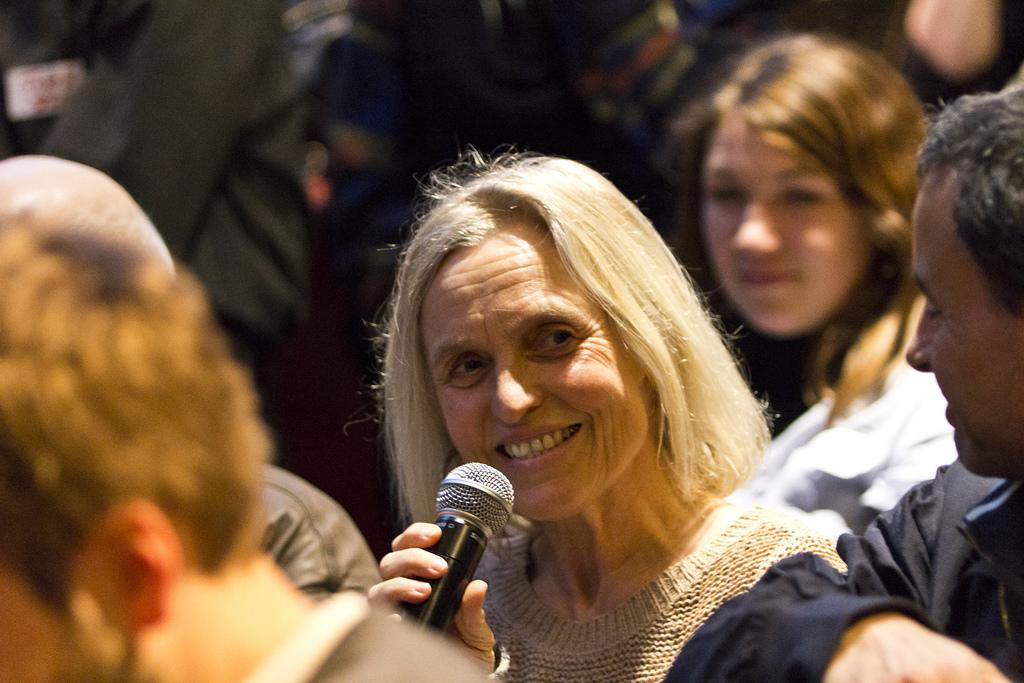Who is present in the image? There are people in the image. What is the facial expression of the people in the image? The people are smiling. Can you describe the woman in the image? The woman is in the image, and she is smiling. What is the woman holding in the image? The woman is holding a microphone. What type of cheese is being used as a wheel in the image? There is no cheese or wheel present in the image. What part of the woman's body is visible in the image? The provided facts do not mention any specific body parts of the woman being visible in the image. 